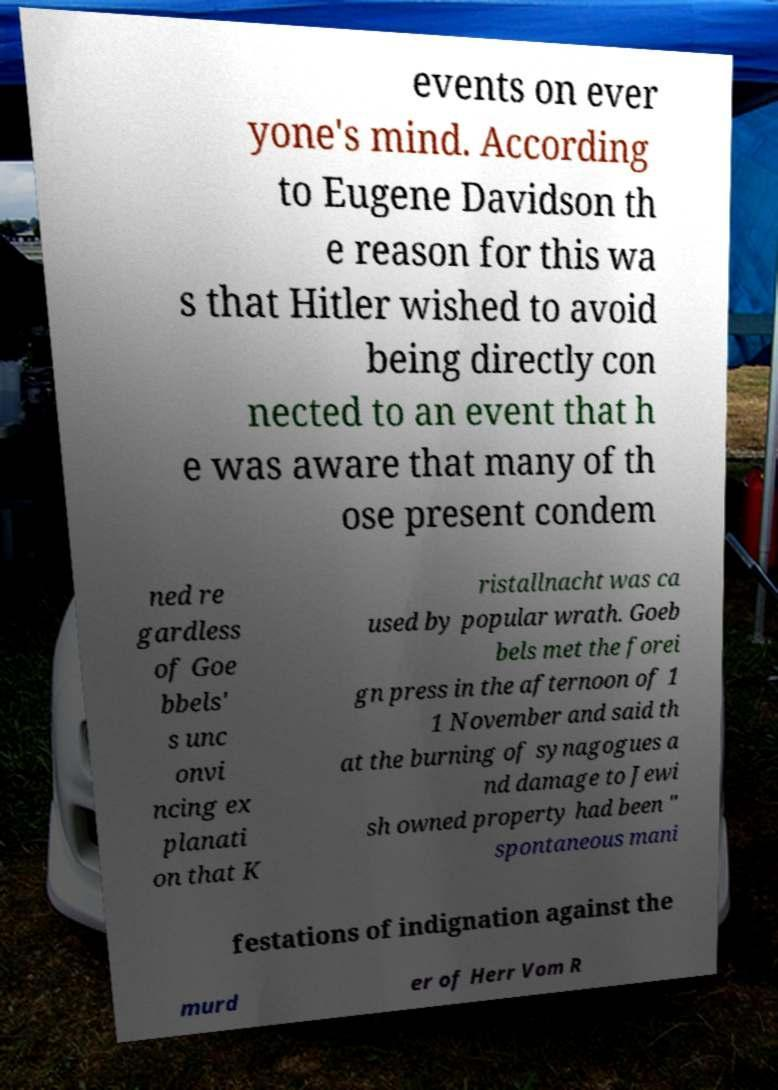What messages or text are displayed in this image? I need them in a readable, typed format. events on ever yone's mind. According to Eugene Davidson th e reason for this wa s that Hitler wished to avoid being directly con nected to an event that h e was aware that many of th ose present condem ned re gardless of Goe bbels' s unc onvi ncing ex planati on that K ristallnacht was ca used by popular wrath. Goeb bels met the forei gn press in the afternoon of 1 1 November and said th at the burning of synagogues a nd damage to Jewi sh owned property had been " spontaneous mani festations of indignation against the murd er of Herr Vom R 